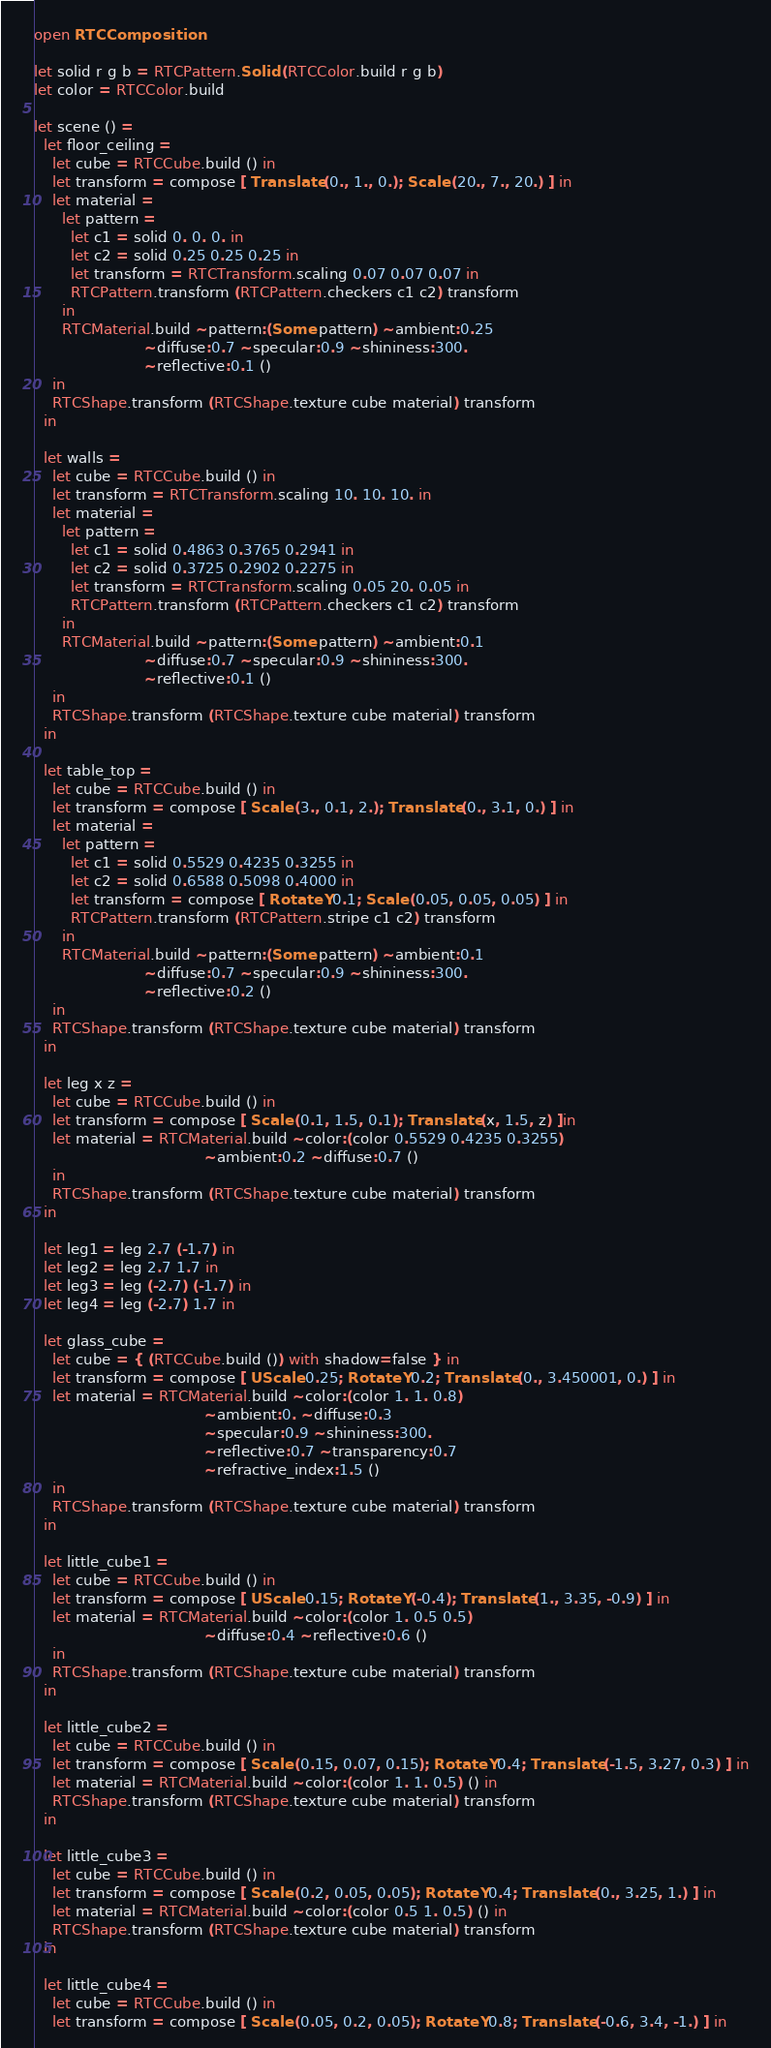Convert code to text. <code><loc_0><loc_0><loc_500><loc_500><_OCaml_>open RTCComposition

let solid r g b = RTCPattern.Solid (RTCColor.build r g b)
let color = RTCColor.build

let scene () =
  let floor_ceiling =
    let cube = RTCCube.build () in
    let transform = compose [ Translate (0., 1., 0.); Scale (20., 7., 20.) ] in
    let material =
      let pattern =
        let c1 = solid 0. 0. 0. in
        let c2 = solid 0.25 0.25 0.25 in
        let transform = RTCTransform.scaling 0.07 0.07 0.07 in
        RTCPattern.transform (RTCPattern.checkers c1 c2) transform
      in
      RTCMaterial.build ~pattern:(Some pattern) ~ambient:0.25
                        ~diffuse:0.7 ~specular:0.9 ~shininess:300.
                        ~reflective:0.1 ()
    in
    RTCShape.transform (RTCShape.texture cube material) transform
  in

  let walls =
    let cube = RTCCube.build () in
    let transform = RTCTransform.scaling 10. 10. 10. in
    let material =
      let pattern =
        let c1 = solid 0.4863 0.3765 0.2941 in
        let c2 = solid 0.3725 0.2902 0.2275 in
        let transform = RTCTransform.scaling 0.05 20. 0.05 in
        RTCPattern.transform (RTCPattern.checkers c1 c2) transform
      in
      RTCMaterial.build ~pattern:(Some pattern) ~ambient:0.1
                        ~diffuse:0.7 ~specular:0.9 ~shininess:300.
                        ~reflective:0.1 ()
    in
    RTCShape.transform (RTCShape.texture cube material) transform
  in

  let table_top =
    let cube = RTCCube.build () in
    let transform = compose [ Scale (3., 0.1, 2.); Translate (0., 3.1, 0.) ] in
    let material =
      let pattern =
        let c1 = solid 0.5529 0.4235 0.3255 in
        let c2 = solid 0.6588 0.5098 0.4000 in
        let transform = compose [ RotateY 0.1; Scale (0.05, 0.05, 0.05) ] in
        RTCPattern.transform (RTCPattern.stripe c1 c2) transform
      in
      RTCMaterial.build ~pattern:(Some pattern) ~ambient:0.1
                        ~diffuse:0.7 ~specular:0.9 ~shininess:300.
                        ~reflective:0.2 ()
    in
    RTCShape.transform (RTCShape.texture cube material) transform
  in

  let leg x z =
    let cube = RTCCube.build () in
    let transform = compose [ Scale (0.1, 1.5, 0.1); Translate (x, 1.5, z) ]in
    let material = RTCMaterial.build ~color:(color 0.5529 0.4235 0.3255)
                                     ~ambient:0.2 ~diffuse:0.7 ()
    in
    RTCShape.transform (RTCShape.texture cube material) transform
  in

  let leg1 = leg 2.7 (-1.7) in
  let leg2 = leg 2.7 1.7 in
  let leg3 = leg (-2.7) (-1.7) in
  let leg4 = leg (-2.7) 1.7 in

  let glass_cube =
    let cube = { (RTCCube.build ()) with shadow=false } in
    let transform = compose [ UScale 0.25; RotateY 0.2; Translate (0., 3.450001, 0.) ] in
    let material = RTCMaterial.build ~color:(color 1. 1. 0.8)
                                     ~ambient:0. ~diffuse:0.3
                                     ~specular:0.9 ~shininess:300.
                                     ~reflective:0.7 ~transparency:0.7
                                     ~refractive_index:1.5 ()
    in
    RTCShape.transform (RTCShape.texture cube material) transform
  in

  let little_cube1 =
    let cube = RTCCube.build () in
    let transform = compose [ UScale 0.15; RotateY (-0.4); Translate (1., 3.35, -0.9) ] in
    let material = RTCMaterial.build ~color:(color 1. 0.5 0.5)
                                     ~diffuse:0.4 ~reflective:0.6 ()
    in
    RTCShape.transform (RTCShape.texture cube material) transform
  in

  let little_cube2 =
    let cube = RTCCube.build () in
    let transform = compose [ Scale (0.15, 0.07, 0.15); RotateY 0.4; Translate (-1.5, 3.27, 0.3) ] in
    let material = RTCMaterial.build ~color:(color 1. 1. 0.5) () in
    RTCShape.transform (RTCShape.texture cube material) transform
  in

  let little_cube3 =
    let cube = RTCCube.build () in
    let transform = compose [ Scale (0.2, 0.05, 0.05); RotateY 0.4; Translate (0., 3.25, 1.) ] in
    let material = RTCMaterial.build ~color:(color 0.5 1. 0.5) () in
    RTCShape.transform (RTCShape.texture cube material) transform
  in

  let little_cube4 =
    let cube = RTCCube.build () in
    let transform = compose [ Scale (0.05, 0.2, 0.05); RotateY 0.8; Translate (-0.6, 3.4, -1.) ] in</code> 